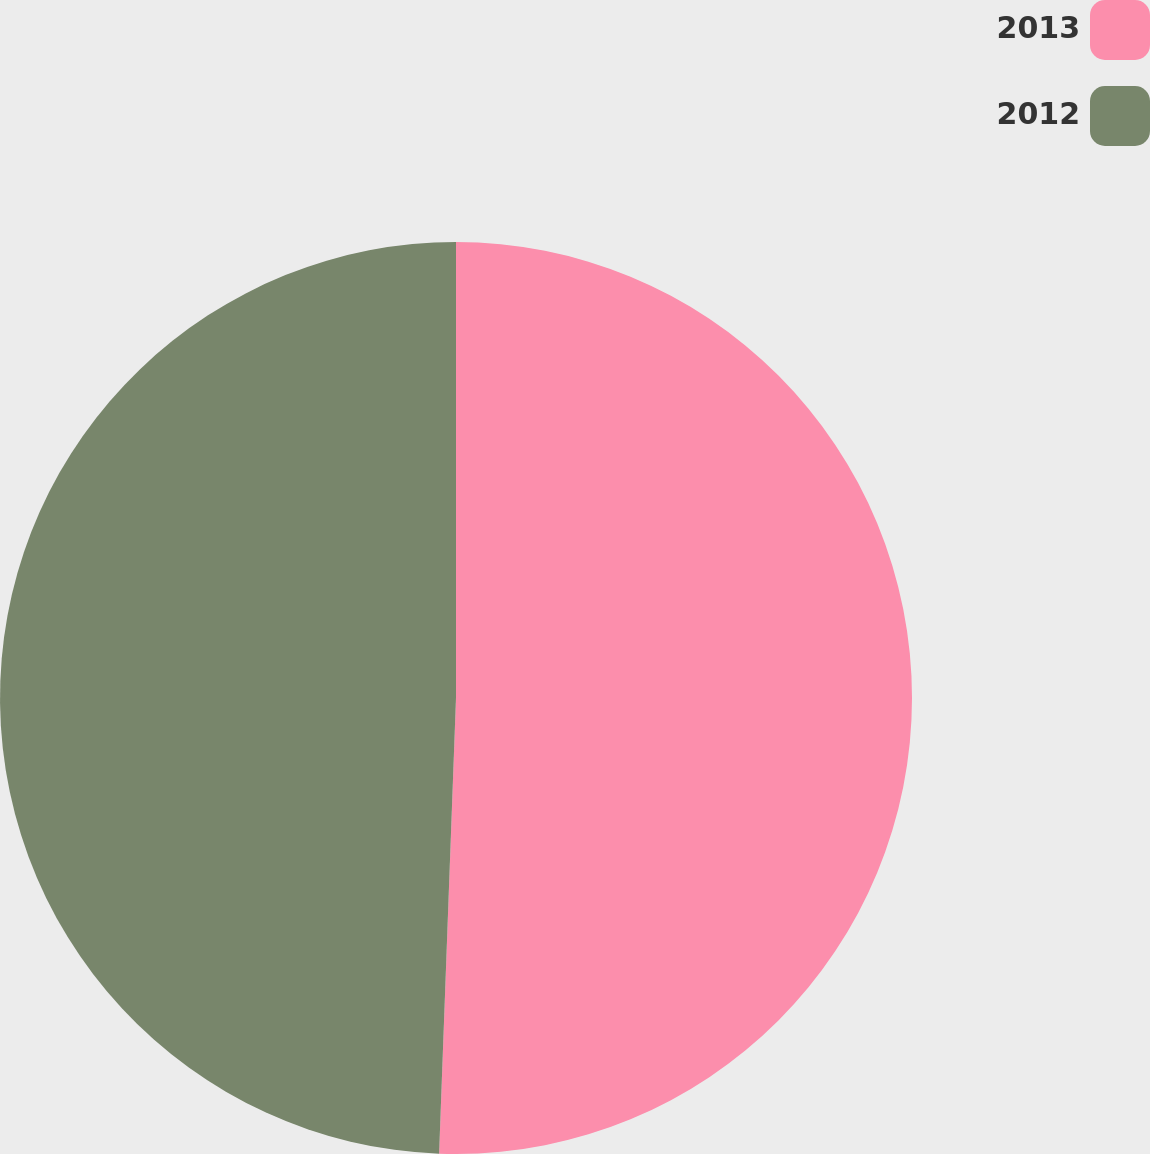Convert chart to OTSL. <chart><loc_0><loc_0><loc_500><loc_500><pie_chart><fcel>2013<fcel>2012<nl><fcel>50.59%<fcel>49.41%<nl></chart> 